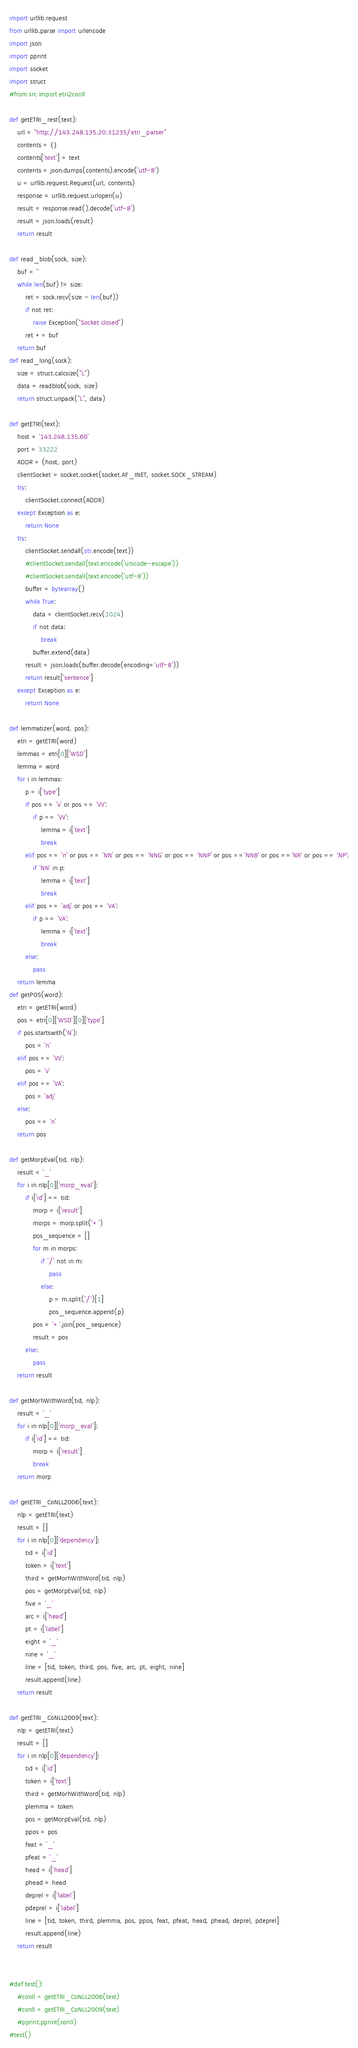<code> <loc_0><loc_0><loc_500><loc_500><_Python_>import urllib.request
from urllib.parse import urlencode
import json
import pprint
import socket
import struct
#from src import etri2conll

def getETRI_rest(text):
    url = "http://143.248.135.20:31235/etri_parser"
    contents = {}
    contents['text'] = text
    contents = json.dumps(contents).encode('utf-8')
    u = urllib.request.Request(url, contents)
    response = urllib.request.urlopen(u)
    result = response.read().decode('utf-8')
    result = json.loads(result)
    return result

def read_blob(sock, size):
    buf = ''
    while len(buf) != size:
        ret = sock.recv(size - len(buf))
        if not ret:
            raise Exception("Socket closed")
        ret += buf
    return buf
def read_long(sock):
    size = struct.calcsize("L")
    data = readblob(sock, size)
    return struct.unpack("L", data)

def getETRI(text):
    host = '143.248.135.60'
    port = 33222
    ADDR = (host, port)
    clientSocket = socket.socket(socket.AF_INET, socket.SOCK_STREAM)
    try:
        clientSocket.connect(ADDR)
    except Exception as e:
        return None
    try:
        clientSocket.sendall(str.encode(text))
        #clientSocket.sendall(text.encode('unicode-escape'))
        #clientSocket.sendall(text.encode('utf-8'))
        buffer = bytearray()
        while True:
            data = clientSocket.recv(1024)
            if not data:
                break
            buffer.extend(data)
        result = json.loads(buffer.decode(encoding='utf-8'))
        return result['sentence']
    except Exception as e:
        return None

def lemmatizer(word, pos):
    etri = getETRI(word)
    lemmas = etri[0]['WSD']
    lemma = word
    for i in lemmas:
        p = i['type']
        if pos == 'v' or pos == 'VV':
            if p == 'VV':
                lemma = i['text']
                break
        elif pos == 'n' or pos == 'NN' or pos == 'NNG' or pos == 'NNP' or pos =='NNB' or pos =='NR' or pos == 'NP':
            if 'NN' in p:
                lemma = i['text']
                break
        elif pos == 'adj' or pos == 'VA':
            if p == 'VA':
                lemma = i['text']
                break
        else:
            pass
    return lemma
def getPOS(word):
    etri = getETRI(word)
    pos = etri[0]['WSD'][0]['type']
    if pos.startswith('N'):
        pos = 'n'
    elif pos == 'VV':
        pos = 'v'
    elif pos == 'VA':
        pos = 'adj'
    else:
        pos == 'n'
    return pos

def getMorpEval(tid, nlp):
    result = '_'
    for i in nlp[0]['morp_eval']:
        if i['id'] == tid:
            morp = i['result']
            morps = morp.split('+')
            pos_sequence = []
            for m in morps:
                if '/' not in m:
                    pass
                else:
                    p = m.split('/')[1]
                    pos_sequence.append(p)
            pos = '+'.join(pos_sequence)
            result = pos
        else:
            pass
    return result

def getMorhWithWord(tid, nlp):
    result = '_'
    for i in nlp[0]['morp_eval']:
        if i['id'] == tid:
            morp = i['result']
            break
    return morp

def getETRI_CoNLL2006(text):
    nlp = getETRI(text)
    result = []
    for i in nlp[0]['dependency']:
        tid = i['id']
        token = i['text']
        third = getMorhWithWord(tid, nlp)
        pos = getMorpEval(tid, nlp)
        five = '_'
        arc = i['head']
        pt = i['label']
        eight = '_'
        nine = '_'
        line = [tid, token, third, pos, five, arc, pt, eight, nine]
        result.append(line)
    return result

def getETRI_CoNLL2009(text):
    nlp = getETRI(text)
    result = []
    for i in nlp[0]['dependency']:
        tid = i['id']
        token = i['text']
        third = getMorhWithWord(tid, nlp)
        plemma = token
        pos = getMorpEval(tid, nlp)
        ppos = pos
        feat = '_'
        pfeat = '_'
        head = i['head']
        phead = head
        deprel = i['label']
        pdeprel = i['label']
        line = [tid, token, third, plemma, pos, ppos, feat, pfeat, head, phead, deprel, pdeprel]
        result.append(line)
    return result


#def test():
    #conll = getETRI_CoNLL2006(text)
    #conll = getETRI_CoNLL2009(text)
    #pprint.pprint(conll)
#test()
</code> 